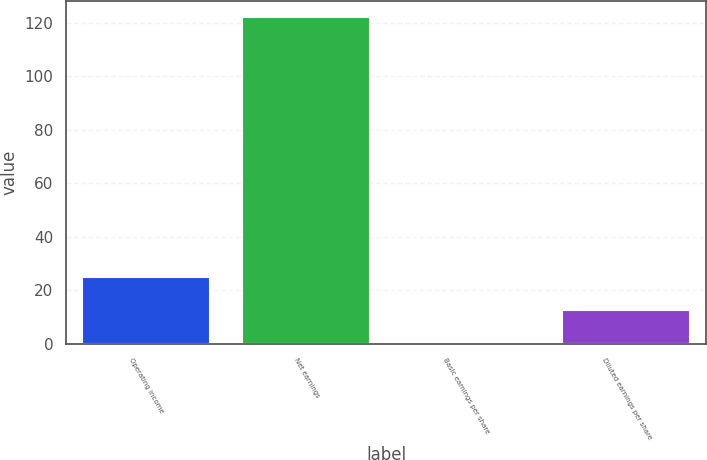Convert chart. <chart><loc_0><loc_0><loc_500><loc_500><bar_chart><fcel>Operating income<fcel>Net earnings<fcel>Basic earnings per share<fcel>Diluted earnings per share<nl><fcel>24.96<fcel>122<fcel>0.7<fcel>12.83<nl></chart> 